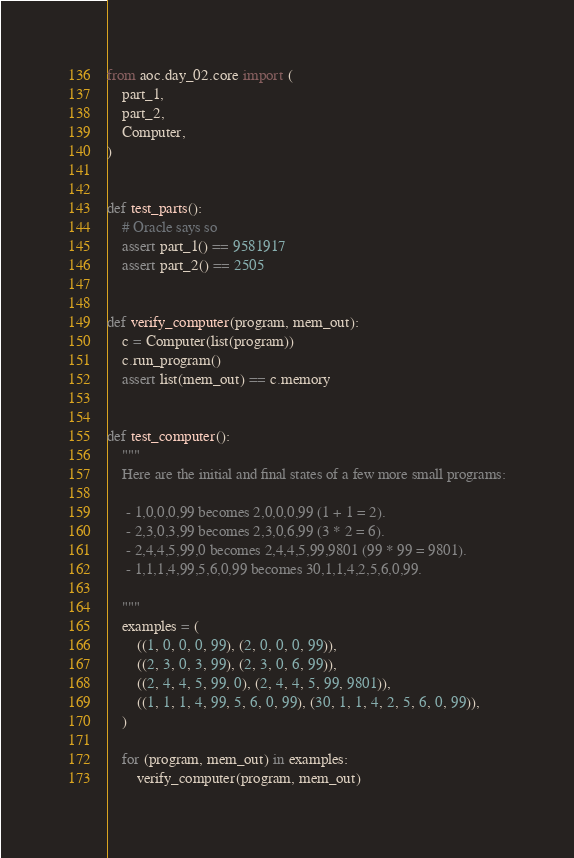<code> <loc_0><loc_0><loc_500><loc_500><_Python_>from aoc.day_02.core import (
    part_1,
    part_2,
    Computer,
)


def test_parts():
    # Oracle says so
    assert part_1() == 9581917
    assert part_2() == 2505


def verify_computer(program, mem_out):
    c = Computer(list(program))
    c.run_program()
    assert list(mem_out) == c.memory


def test_computer():
    """
    Here are the initial and final states of a few more small programs:

     - 1,0,0,0,99 becomes 2,0,0,0,99 (1 + 1 = 2).
     - 2,3,0,3,99 becomes 2,3,0,6,99 (3 * 2 = 6).
     - 2,4,4,5,99,0 becomes 2,4,4,5,99,9801 (99 * 99 = 9801).
     - 1,1,1,4,99,5,6,0,99 becomes 30,1,1,4,2,5,6,0,99.

    """
    examples = (
        ((1, 0, 0, 0, 99), (2, 0, 0, 0, 99)),
        ((2, 3, 0, 3, 99), (2, 3, 0, 6, 99)),
        ((2, 4, 4, 5, 99, 0), (2, 4, 4, 5, 99, 9801)),
        ((1, 1, 1, 4, 99, 5, 6, 0, 99), (30, 1, 1, 4, 2, 5, 6, 0, 99)),
    )

    for (program, mem_out) in examples:
        verify_computer(program, mem_out)
</code> 